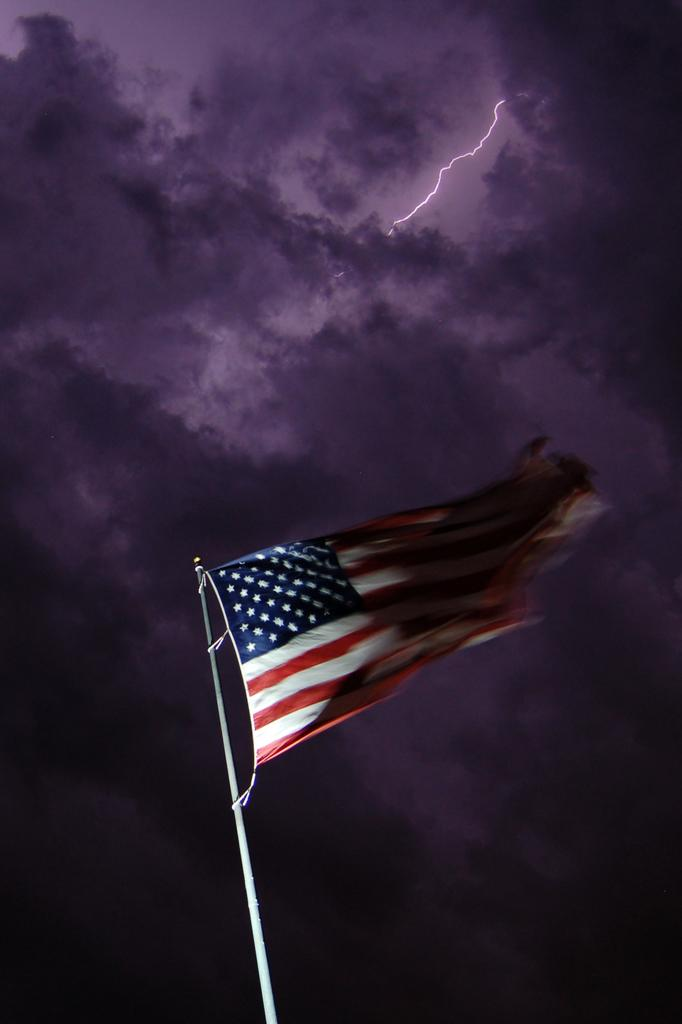What is the main subject in the center of the image? There is a flag in the center of the image. What is the flag attached to? The flag is attached to a pole. What can be seen in the sky in the image? There are clouds in the sky. What weather condition can be inferred from the presence of thunder in the image? The presence of thunder suggests that it might be stormy or rainy in the image. How much does the judge weigh in the image? There is no judge present in the image; it features a flag and a pole. How many times does the push occur in the image? There is no pushing activity depicted in the image. 